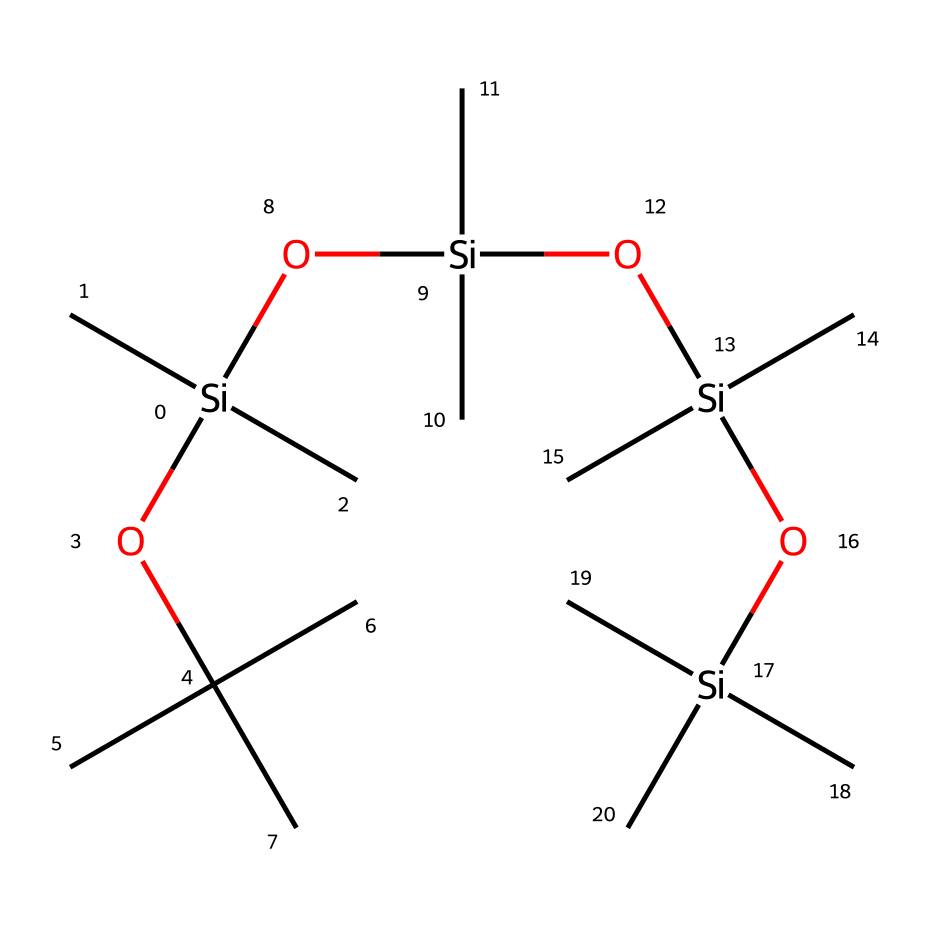What type of compound is represented in the SMILES notation? The SMILES notation depicts a silicone compound since it features silicon (Si) atoms in a chain structure, characteristic of silicones.
Answer: silicone How many silicon atoms are present in the chemical structure? By examining the SMILES representation, we can count four occurrences of 'Si', indicating there are four silicon atoms in the structure.
Answer: 4 How many carbon atoms are connected to each silicon atom? Analyzing the structure reveals that each silicon atom is bonded to three carbon atoms, as each Si is followed by three 'C' in the SMILES notation.
Answer: 3 What functional groups are present in this lubricant? The compound includes silanol groups (due to the presence of O and H bonded to Si) which are characteristic of silicone-based lubricants.
Answer: silanol What is the primary benefit of using silicone-based lubricants in lacrosse equipment? Silicone-based lubricants provide excellent lubrication and water resistance, making them ideal for maintaining lacrosse gear.
Answer: water resistance How does the branching in the structure affect the viscosity of this lubricant? The branched structure typically leads to lower viscosity due to reduced intermolecular interactions compared to linear forms, providing smoother application.
Answer: lower viscosity What is likely a key property of this lubricant that makes it suitable for high-performance sports equipment? The lubricating properties of silicone-based compounds ensure durability and stability under varying temperature and pressure conditions of intense sports.
Answer: durability 